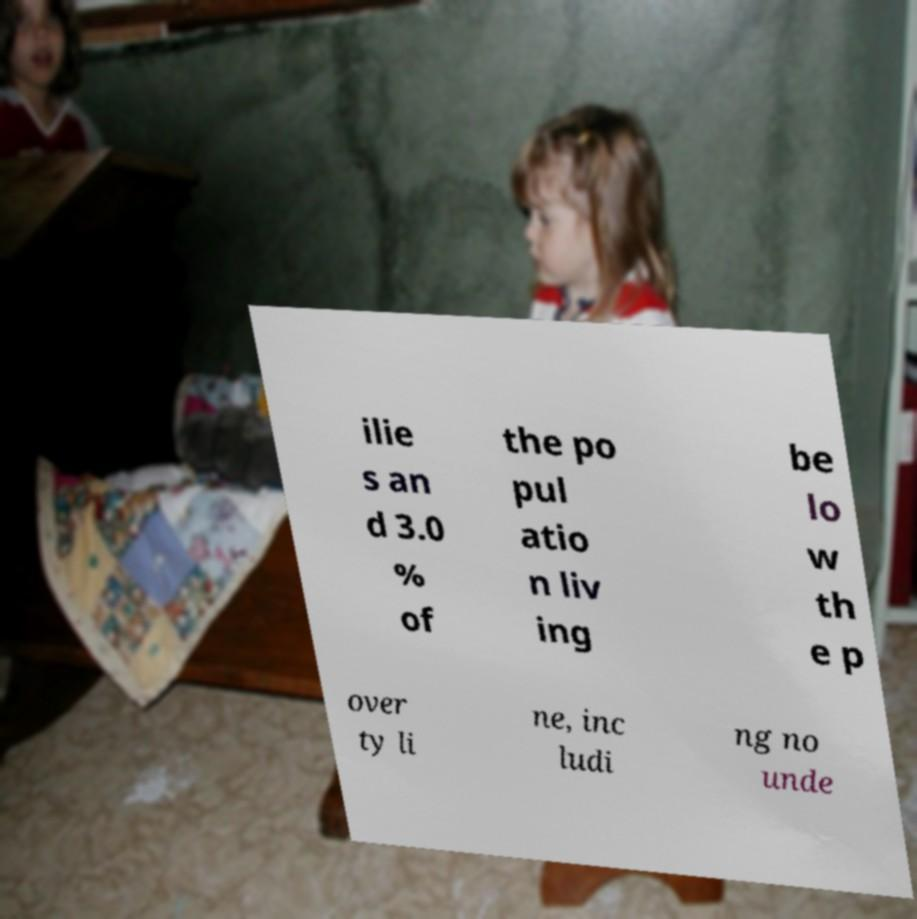Could you extract and type out the text from this image? ilie s an d 3.0 % of the po pul atio n liv ing be lo w th e p over ty li ne, inc ludi ng no unde 